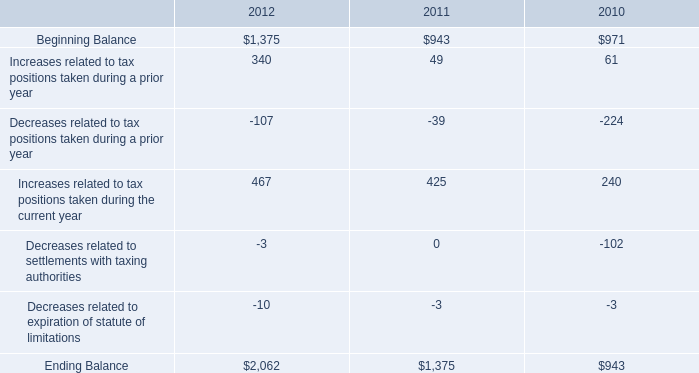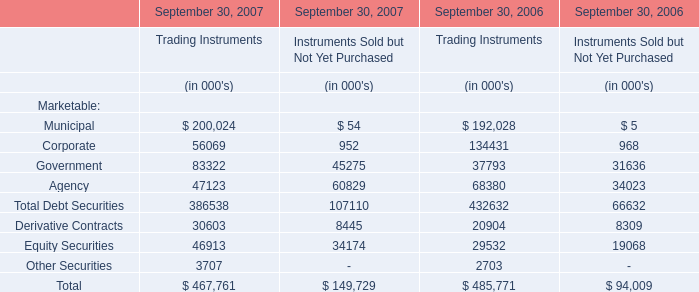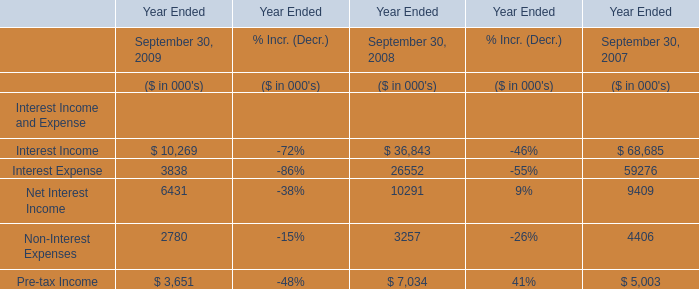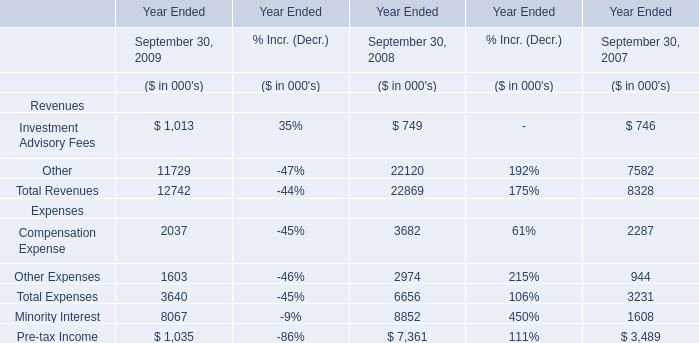Does Investment Advisory Fees keeps increasing each year between 2008 and 2009? 
Answer: yes. 